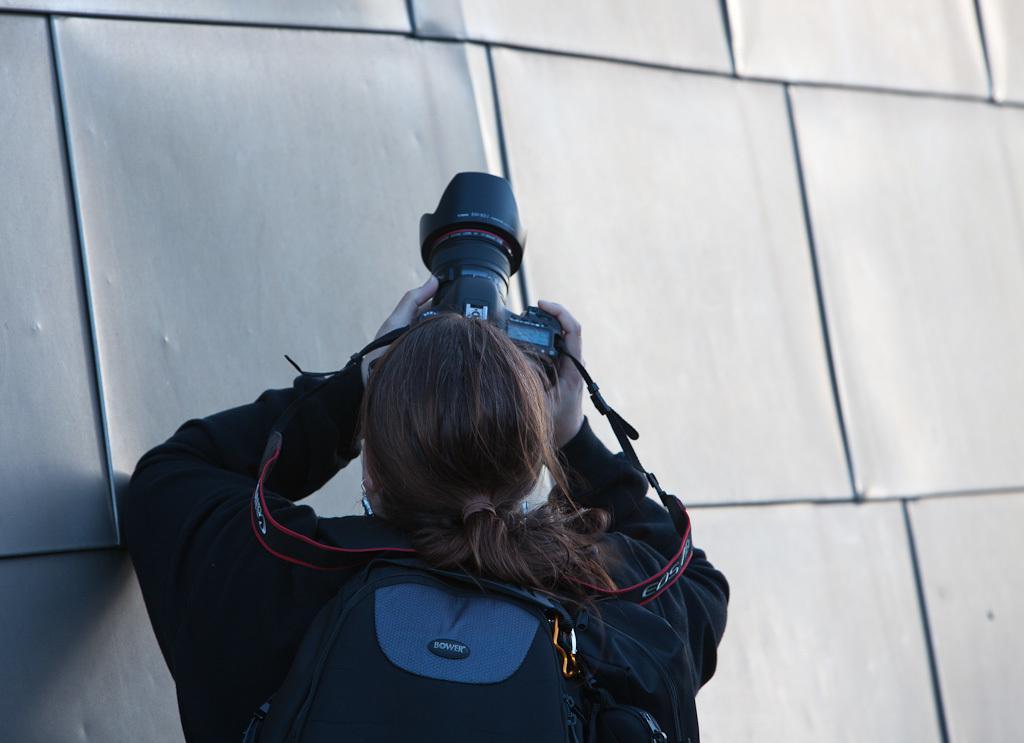Describe this image in one or two sentences. In this picture we can see a person carrying a bag, holding a camera and in front of this person we can see the wall. 